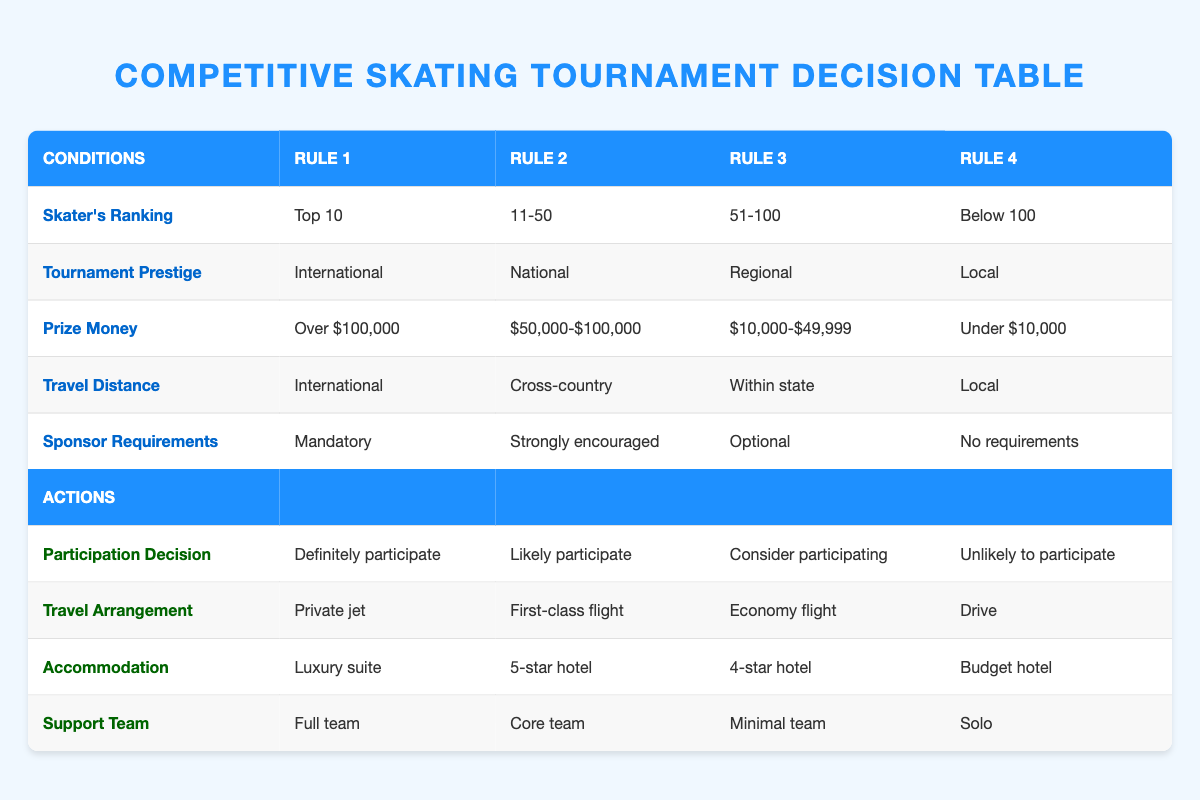What is the travel arrangement for a skater with a ranking in the Top 10 participating in an International tournament? According to Rule 1 in the table, if a skater is ranked in the Top 10 and participates in an International tournament with over $100,000 prize money and mandatory sponsor requirements, the travel arrangement is a private jet.
Answer: Private jet For a skater ranked 51-100, what kind of accommodation can they expect if they consider participating in a Regional tournament? Referring to Rule 3 for skaters ranked 51-100 who are considering participation in a Regional tournament with prize money ranging from $10,000 to $49,999, they can expect accommodation in a 4-star hotel.
Answer: 4-star hotel Is it mandatory for sponsors to be involved if a skater ranked Below 100 is participating in a Local tournament? In Rule 4, it states that there are no sponsor requirements for skaters ranked Below 100 participating in a Local tournament with under $10,000 prize money. Therefore, it is not mandatory for sponsors.
Answer: No How many different travel arrangements are associated with the 'Definitely participate' decision? The first rule indicates a private jet for the 'Definitely participate' decision, and there are no other rules that result in this action. Thus, there is only one specific travel arrangement associated with this participation decision.
Answer: 1 What is the average ranking range of skaters who are likely to participate? The 'Likely participate' status applies to skaters ranked 11-50. Since this is one specified range, we consider this group's average ranking range as simply (11+50)/2=30.5, but as it's a single grouping, the range is from 11 to 50 without needing to average.
Answer: 11-50 What support team size is expected if a skater is likely to participate in a National tournament? Looking at Rule 2, for skaters ranked 11-50 participating in a National tournament with $50,000-$100,000 prize money, they are expected to have a core team as their support team size.
Answer: Core team Would a skater participating in a Regional tournament with optional sponsor requirements travel by private jet? According to Rule 3, a skater ranked 51-100 participating in a Regional tournament with $10,000-$49,999 prize money and optional sponsor requirements would have an economy flight as their travel arrangement. Thus, they would not travel by private jet.
Answer: No For a local tournament with no sponsor requirements, what is the participation decision for skaters ranked Below 100? According to Rule 4, the participation decision for skaters ranked Below 100 in a Local tournament with under $10,000 prize money and no sponsor requirements is categorized as unlikely to participate.
Answer: Unlikely to participate 